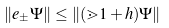<formula> <loc_0><loc_0><loc_500><loc_500>\| e _ { \pm } \Psi \| \leq \| ( \mathbb { m } 1 + h ) \Psi \|</formula> 